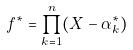Convert formula to latex. <formula><loc_0><loc_0><loc_500><loc_500>f ^ { * } = \prod _ { k = 1 } ^ { n } ( X - \alpha _ { k } ^ { * } )</formula> 